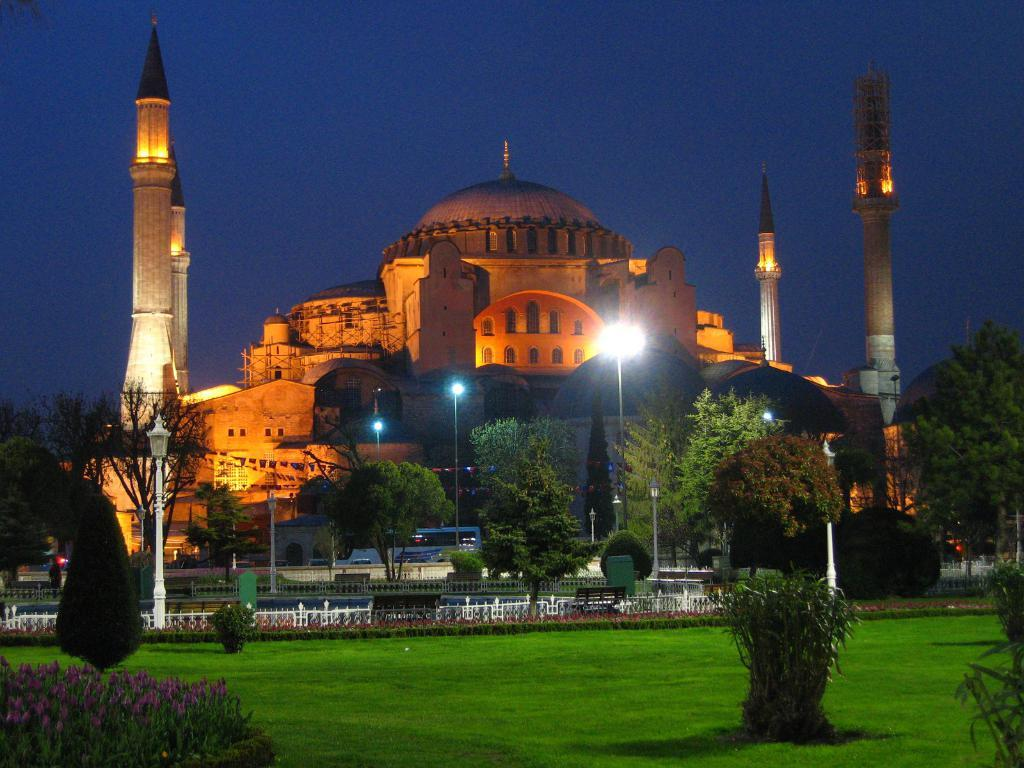What type of structure is present in the picture? There is a fort in the picture. What type of barrier can be seen in the picture? There is a fence in the picture. What type of lighting is present in the picture? There are pole lights in the picture. What type of vegetation is visible in the picture? The grass, plants, and trees are visible in the picture. What part of the natural environment is visible in the background of the picture? The sky is visible in the background of the picture. What type of jeans is the fort wearing in the picture? The fort is not a person and therefore cannot wear jeans. 